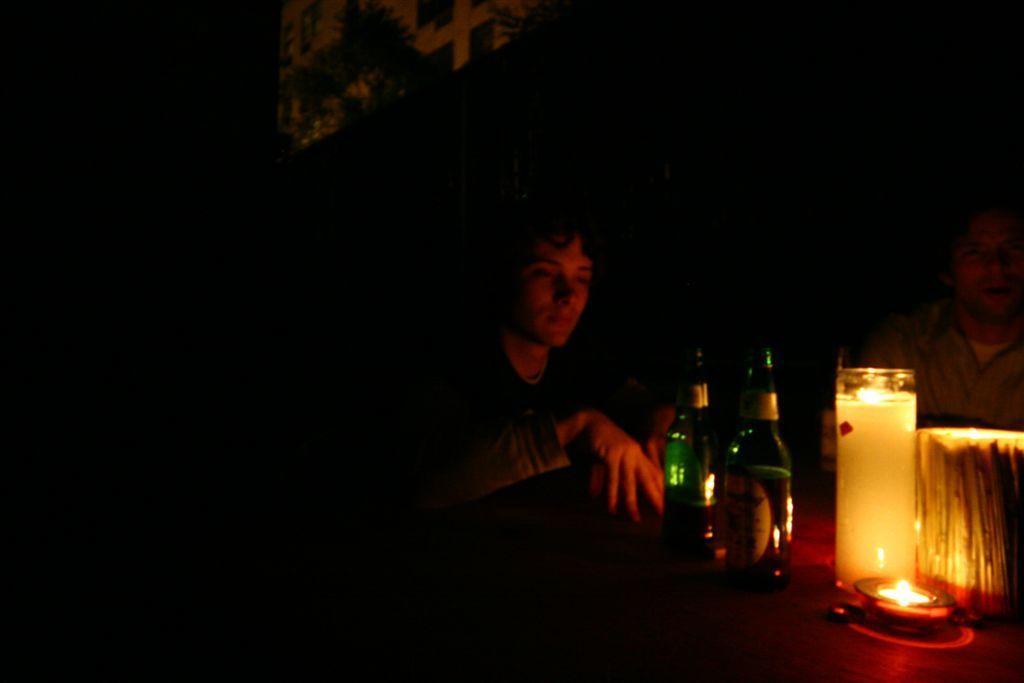In one or two sentences, can you explain what this image depicts? In this picture we can see there are two people and in front of the people there are bottles, candle and other things. Behind the people there is a dark background. 